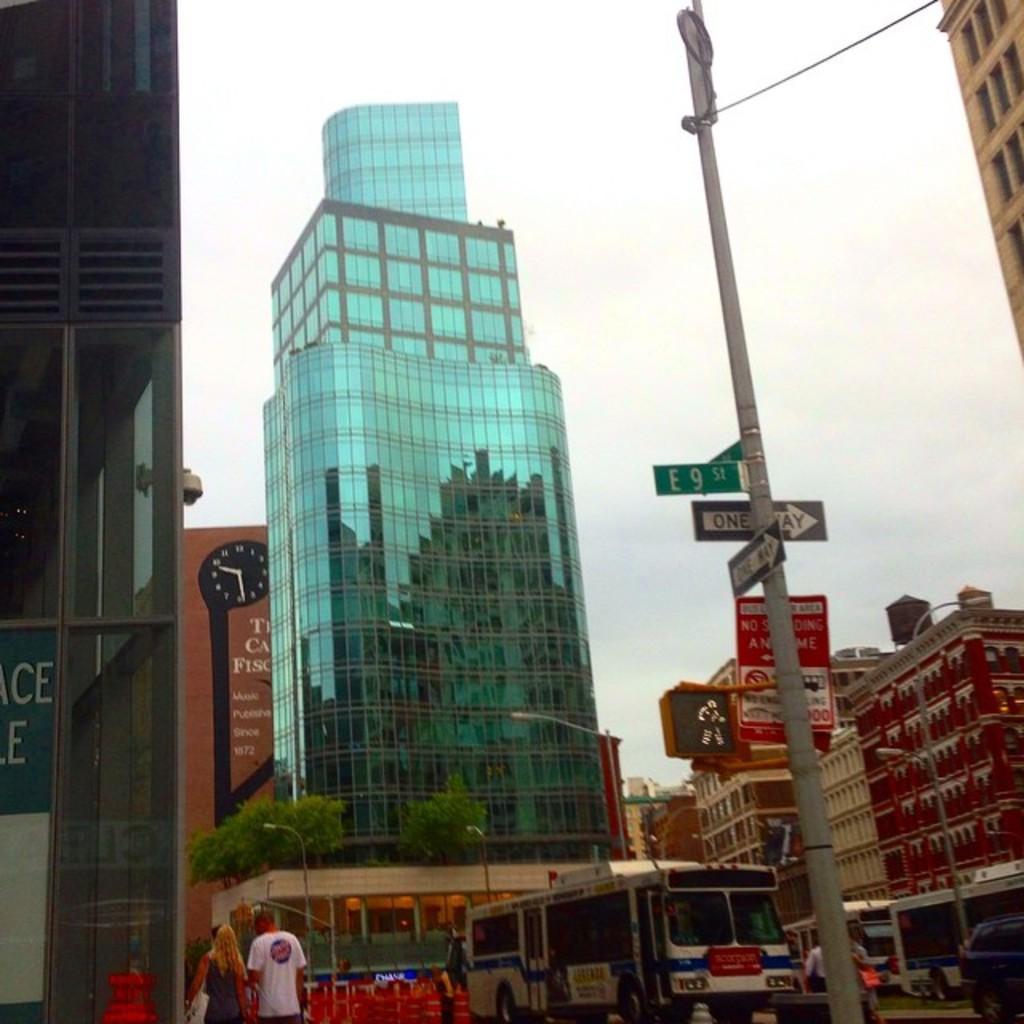Describe this image in one or two sentences. In this image we can see a group of buildings, trees, a board with some text on it, a street sign, some poles, vehicles and some people on the ground and the sky which looks cloudy. 